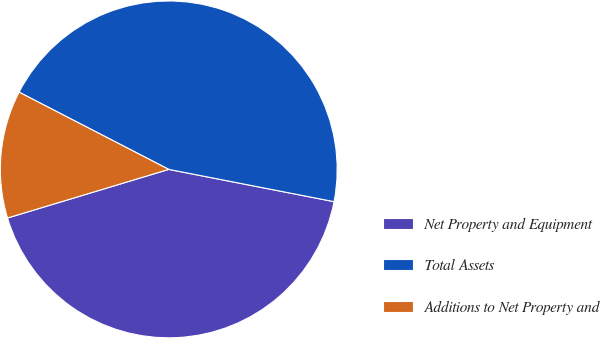Convert chart. <chart><loc_0><loc_0><loc_500><loc_500><pie_chart><fcel>Net Property and Equipment<fcel>Total Assets<fcel>Additions to Net Property and<nl><fcel>42.27%<fcel>45.49%<fcel>12.24%<nl></chart> 